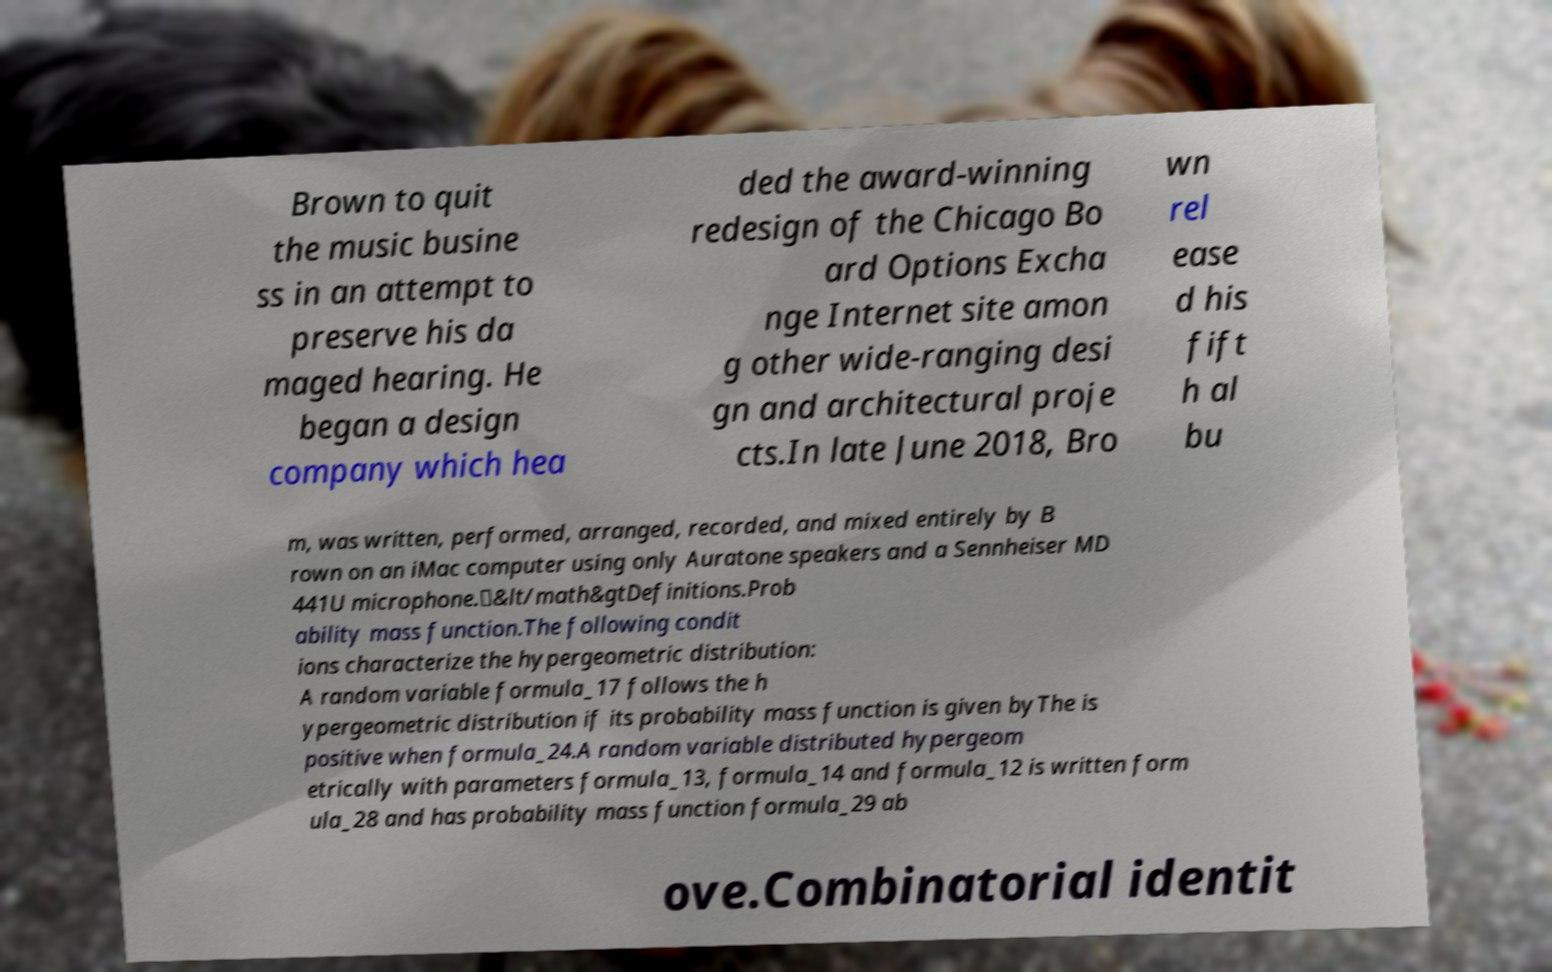Can you read and provide the text displayed in the image?This photo seems to have some interesting text. Can you extract and type it out for me? Brown to quit the music busine ss in an attempt to preserve his da maged hearing. He began a design company which hea ded the award-winning redesign of the Chicago Bo ard Options Excha nge Internet site amon g other wide-ranging desi gn and architectural proje cts.In late June 2018, Bro wn rel ease d his fift h al bu m, was written, performed, arranged, recorded, and mixed entirely by B rown on an iMac computer using only Auratone speakers and a Sennheiser MD 441U microphone.\&lt/math&gtDefinitions.Prob ability mass function.The following condit ions characterize the hypergeometric distribution: A random variable formula_17 follows the h ypergeometric distribution if its probability mass function is given byThe is positive when formula_24.A random variable distributed hypergeom etrically with parameters formula_13, formula_14 and formula_12 is written form ula_28 and has probability mass function formula_29 ab ove.Combinatorial identit 